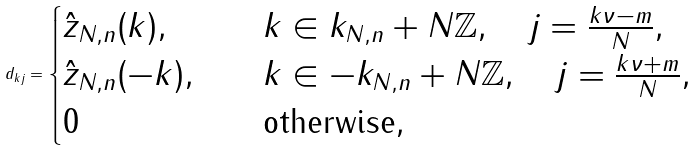Convert formula to latex. <formula><loc_0><loc_0><loc_500><loc_500>d _ { k j } = \begin{cases} \hat { z } _ { N , n } ( k ) , & \quad k \in k _ { N , n } + N \mathbb { Z } , \quad j = \frac { k \nu - m } { N } , \\ \hat { z } _ { N , n } ( - k ) , & \quad k \in - k _ { N , n } + N \mathbb { Z } , \quad j = \frac { k \nu + m } { N } , \\ 0 & \quad \text {otherwise} , \end{cases}</formula> 